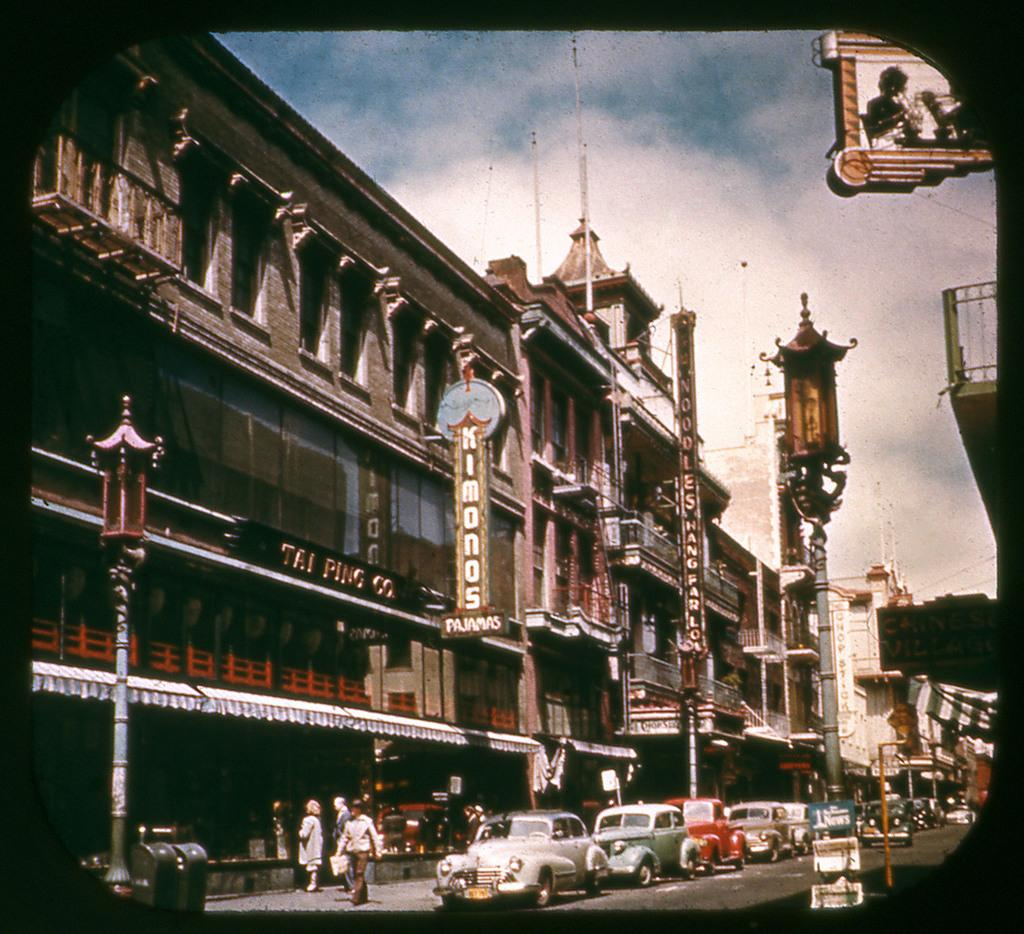<image>
Relay a brief, clear account of the picture shown. Several cars are parked in front of the Tai Ping Co. building. 